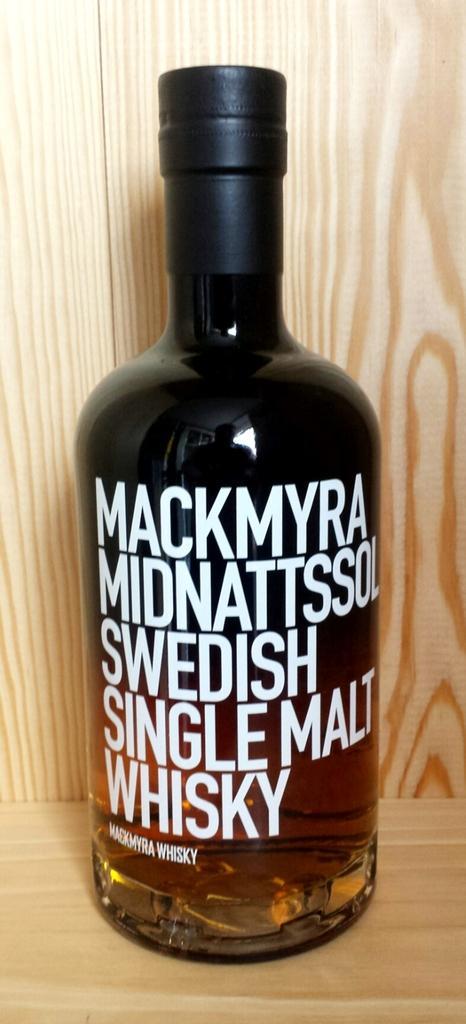Describe this image in one or two sentences. In this image there is a bottle. It is black in color. In that there is a whiskey. The bottle is kept in a wooden rack. 